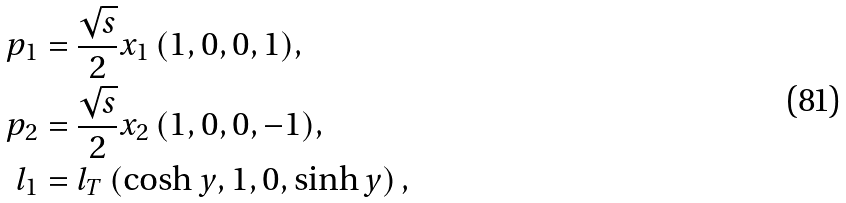Convert formula to latex. <formula><loc_0><loc_0><loc_500><loc_500>p _ { 1 } & = \frac { \sqrt { s } } { 2 } x _ { 1 } \, ( 1 , 0 , 0 , 1 ) , \\ p _ { 2 } & = \frac { \sqrt { s } } { 2 } x _ { 2 } \, ( 1 , 0 , 0 , - 1 ) , \\ l _ { 1 } & = l _ { T } \left ( \cosh y , 1 , 0 , \sinh y \right ) ,</formula> 